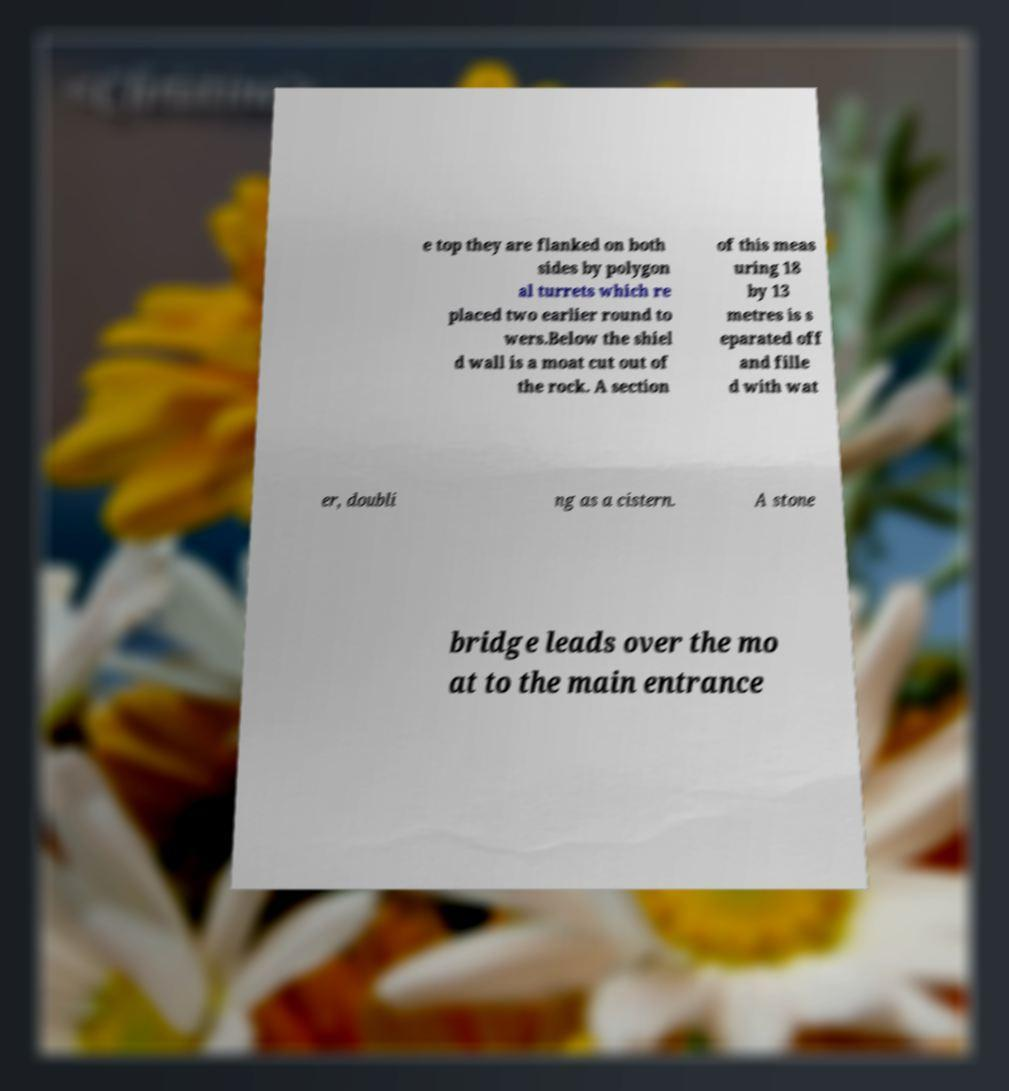For documentation purposes, I need the text within this image transcribed. Could you provide that? e top they are flanked on both sides by polygon al turrets which re placed two earlier round to wers.Below the shiel d wall is a moat cut out of the rock. A section of this meas uring 18 by 13 metres is s eparated off and fille d with wat er, doubli ng as a cistern. A stone bridge leads over the mo at to the main entrance 